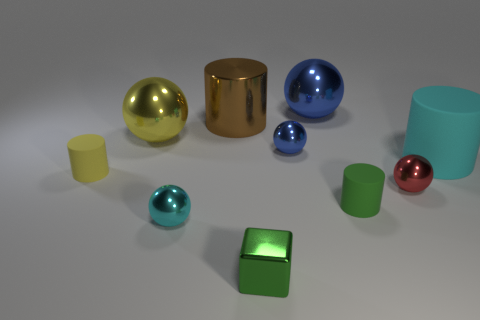Subtract all cyan spheres. How many spheres are left? 4 Subtract all cyan balls. How many balls are left? 4 Subtract 2 balls. How many balls are left? 3 Subtract all purple balls. Subtract all brown cylinders. How many balls are left? 5 Subtract all cubes. How many objects are left? 9 Subtract 0 purple cubes. How many objects are left? 10 Subtract all gray balls. Subtract all tiny objects. How many objects are left? 4 Add 7 blue objects. How many blue objects are left? 9 Add 1 big gray matte objects. How many big gray matte objects exist? 1 